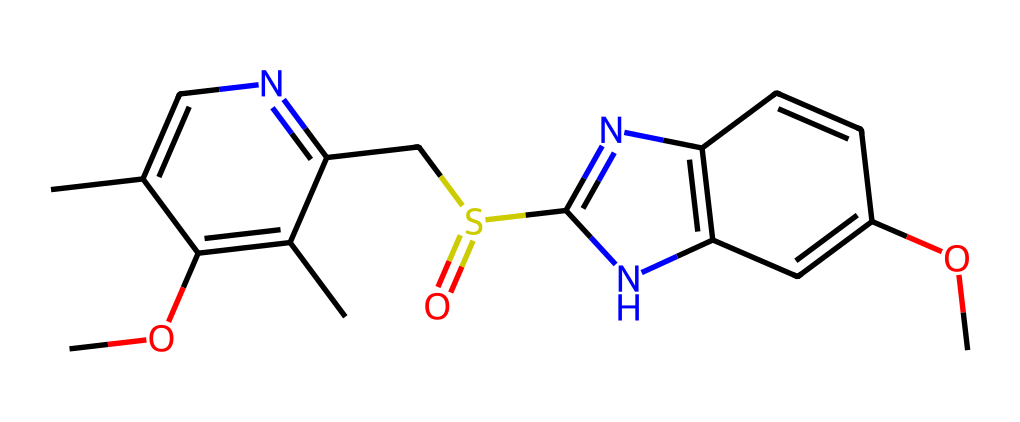What is the chemical formula of omeprazole? The chemical formula can be derived from the SMILES representation by counting the atoms present. The structure shows 17 Carbon (C), 19 Hydrogen (H), 3 Nitrogen (N), 2 Oxygen (O), and 1 Sulfur (S) atom. Therefore, the formula is C17H19N3O3S.
Answer: C17H19N3O3S How many rings are present in the molecular structure? By analyzing the structure through the SMILES, we can identify two distinct ring systems. One is a six-membered ring and the other is a five-membered ring, hence there are two rings in total.
Answer: 2 What is the primary use of omeprazole? Omeprazole is primarily used as a proton pump inhibitor, which is indicated for conditions such as acid reflux and peptic ulcers.
Answer: proton pump inhibitor Which functional groups can be identified in omeprazole? Observing the structure, we can identify several functional groups such as a sulfonyl group (-SO2-) and ether groups (-O-), which play key roles in its activity.
Answer: sulfonyl and ether groups How many carbon atoms are in omeprazole? From the molecular composition derived from the SMILES, there are a total of 17 Carbon atoms in omeprazole.
Answer: 17 What is the main pharmacological action of omeprazole? Omeprazole acts by inhibiting the H+/K+ ATPase enzyme in the stomach lining, effectively reducing gastric acid production, which is crucial for its therapeutic effect.
Answer: reduces gastric acid production 